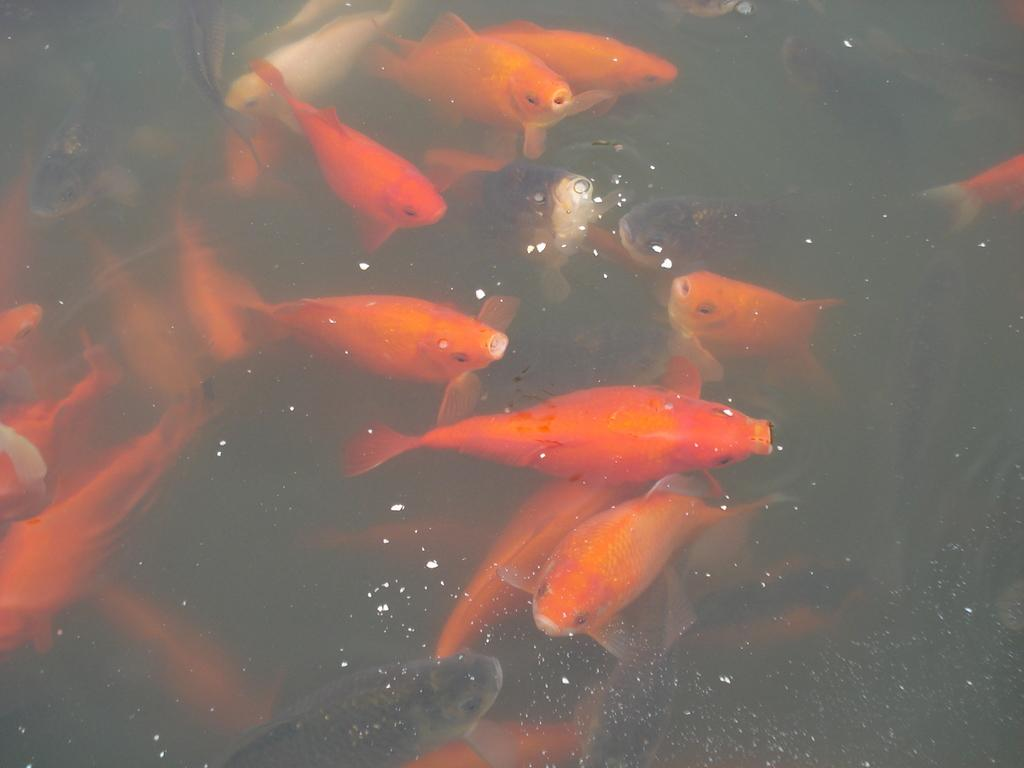What type of animals can be seen in the water in the image? There are fishes in the water in the image. What is present in the water along with the fishes? There is some dust in the water. What emotion can be seen on the faces of the fishes in the image? The image does not show the faces of the fishes, so it is not possible to determine their emotions. 